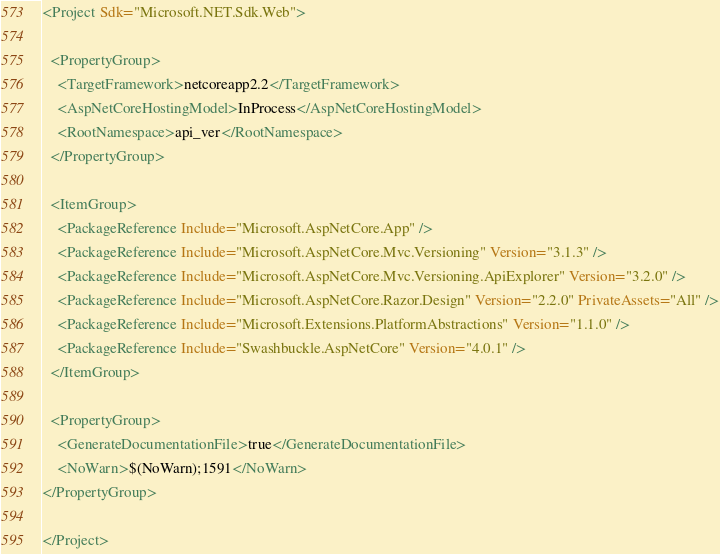Convert code to text. <code><loc_0><loc_0><loc_500><loc_500><_XML_><Project Sdk="Microsoft.NET.Sdk.Web">

  <PropertyGroup>
    <TargetFramework>netcoreapp2.2</TargetFramework>
    <AspNetCoreHostingModel>InProcess</AspNetCoreHostingModel>
    <RootNamespace>api_ver</RootNamespace>
  </PropertyGroup>

  <ItemGroup>
    <PackageReference Include="Microsoft.AspNetCore.App" />
    <PackageReference Include="Microsoft.AspNetCore.Mvc.Versioning" Version="3.1.3" />
    <PackageReference Include="Microsoft.AspNetCore.Mvc.Versioning.ApiExplorer" Version="3.2.0" />
    <PackageReference Include="Microsoft.AspNetCore.Razor.Design" Version="2.2.0" PrivateAssets="All" />
    <PackageReference Include="Microsoft.Extensions.PlatformAbstractions" Version="1.1.0" />
    <PackageReference Include="Swashbuckle.AspNetCore" Version="4.0.1" />
  </ItemGroup>

  <PropertyGroup>
    <GenerateDocumentationFile>true</GenerateDocumentationFile>
    <NoWarn>$(NoWarn);1591</NoWarn>
</PropertyGroup>

</Project>
</code> 